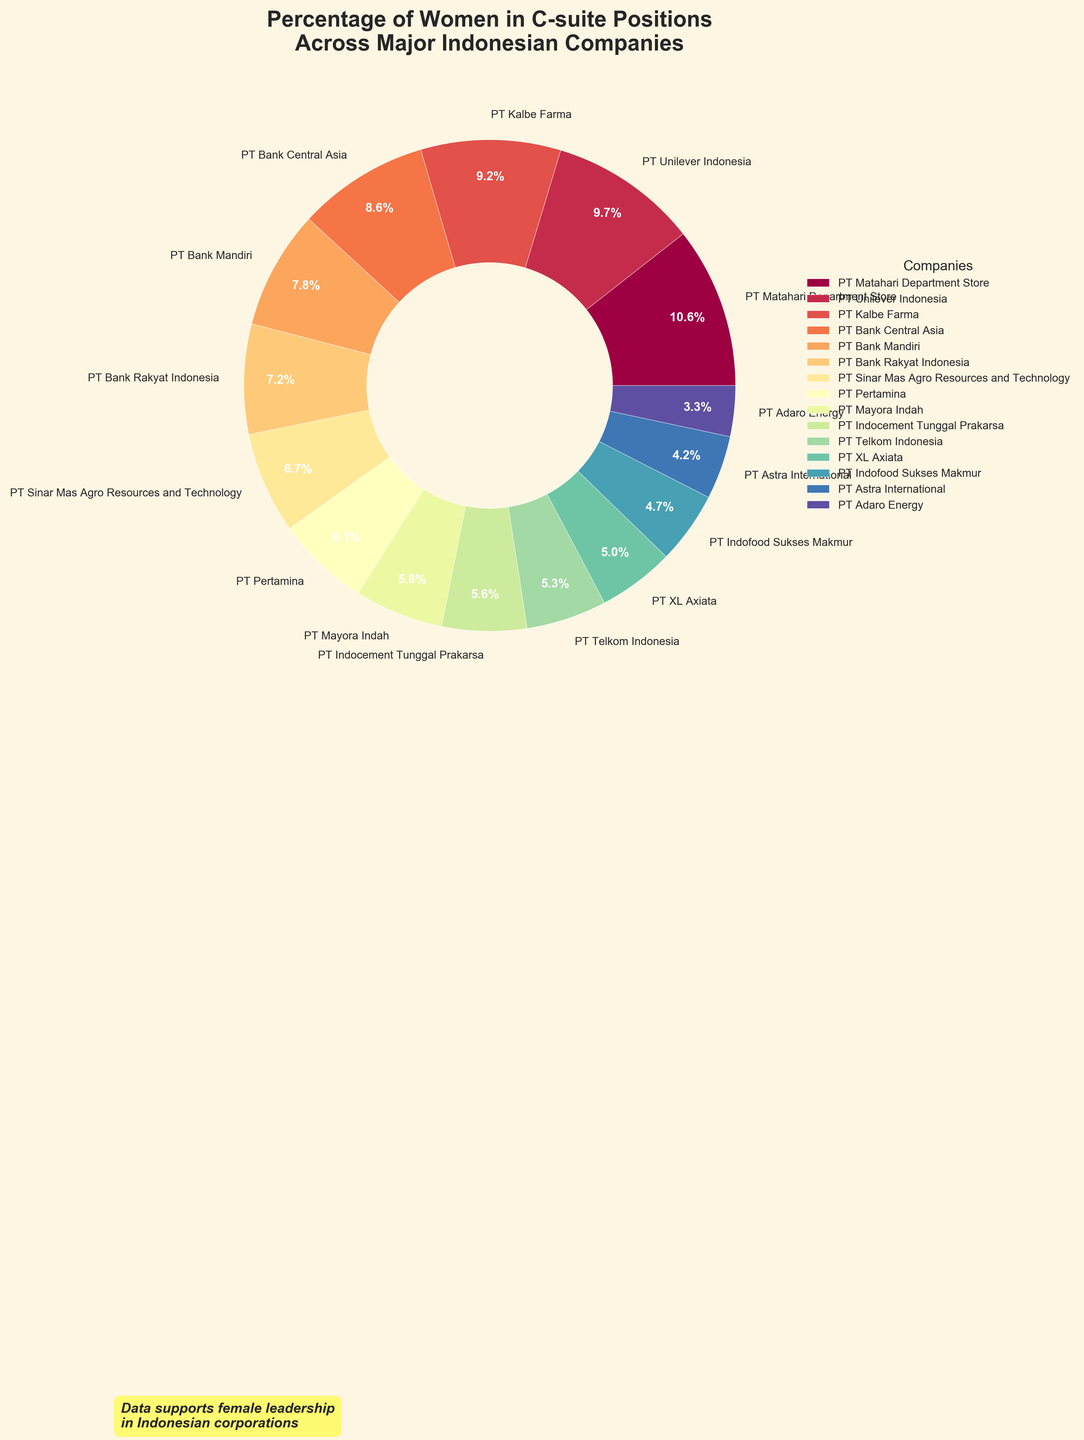what percentage of women are in C-suite positions at PT Matahari Department Store? The pie chart shows that PT Matahari Department Store has a colored wedge with a label indicating 38%.
Answer: 38% Which company has the lowest percentage of women in C-suite positions? The pie chart indicates that PT Adaro Energy has the lowest percentage, which is marked at 12%.
Answer: PT Adaro Energy Which company has a higher percentage of women in C-suite positions: PT Bank Mandiri or PT Kalbe Farma? According to the pie chart, PT Kalbe Farma has 33% while PT Bank Mandiri has 28%, so PT Kalbe Farma has a higher percentage.
Answer: PT Kalbe Farma What's the average percentage of women in C-suite positions across PT Bank Mandiri, PT Pertamina, and PT Telkom Indonesia? The percentages are 28%, 22%, and 19% respectively. The sum is 28 + 22 + 19 = 69. The average is 69/3 = 23%.
Answer: 23% Are there more companies with a percentage of women in C-suite positions below 20% or above 20%? From the pie chart, we have PT Telkom Indonesia (19%), PT Astra International (15%), PT Indofood Sukses Makmur (17%), PT Adaro Energy (12%), and PT XL Axiata (18%) below 20% which accounts for 5 companies. The rest have percentages above 20%.
Answer: Above 20% How many companies have a percentage of women in C-suite positions between 20% and 30%? By examining the pie chart, PT Pertamina (22%), PT Bank Central Asia (31%, excluded), PT Sinar Mas Agro Resources (24%), PT Indocement Tunggal Prakarsa (20.5%, excluded), PT Bank Rakyat Indonesia (26%), PT Mayora Indah (21%) fit into this range. We exclude companies exactly at 20% or 30%. Therefore, there are 4 companies in this range.
Answer: 4 What's the difference in the percentage of women between PT XL Axiata and PT Sinar Mas Agro Resources and Technology? PT XL Axiata has 18% while PT Sinar Mas Agro Resources has 24%. The difference is 24% - 18% = 6%.
Answer: 6% Which company has the second highest percentage of women in C-suite positions? The pie chart shows PT Unilever Indonesia with 35%, which is the second highest after PT Matahari Department Store (38%).
Answer: PT Unilever Indonesia What is the total percentage of women in C-suite positions for PT Bank Central Asia, PT Kalbe Farma, and PT Indocement Tunggal Prakarsa combined? PT Bank Central Asia (31%), PT Kalbe Farma (33%), PT Indocement Tunggal Prakarsa (20%). Total is 31% + 33% + 20% = 84%.
Answer: 84% 